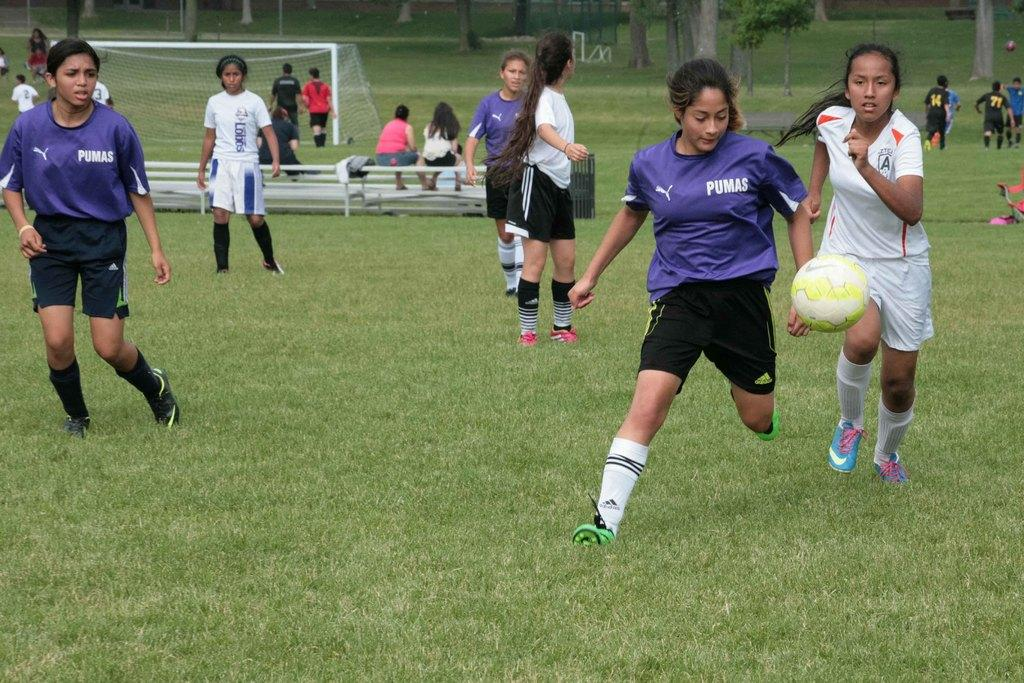Provide a one-sentence caption for the provided image. Two teams of young women are playing soccer with Pumas jerseys. 